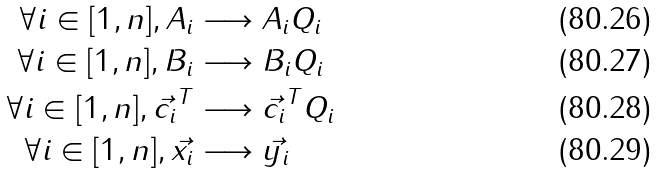Convert formula to latex. <formula><loc_0><loc_0><loc_500><loc_500>\forall i \in [ 1 , n ] , A _ { i } & \longrightarrow A _ { i } Q _ { i } \\ \forall i \in [ 1 , n ] , B _ { i } & \longrightarrow B _ { i } Q _ { i } \\ \forall i \in [ 1 , n ] , \vec { c _ { i } } ^ { T } & \longrightarrow \vec { c _ { i } } ^ { T } Q _ { i } \\ \forall i \in [ 1 , n ] , \vec { x _ { i } } & \longrightarrow \vec { y _ { i } }</formula> 